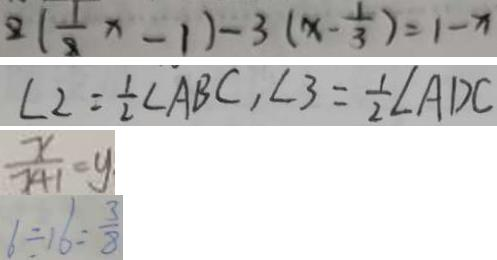<formula> <loc_0><loc_0><loc_500><loc_500>2 ( \frac { 1 } { 2 } x - 1 ) - 3 ( x - \frac { 1 } { 3 } ) = 1 - x 
 \angle 2 = \frac { 1 } { 2 } \angle A B C , \angle 3 = \frac { 1 } { 2 } \angle A D C 
 \frac { x } { 2 4 1 } = y 
 6 \div 1 6 = \frac { 3 } { 8 }</formula> 